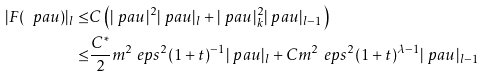<formula> <loc_0><loc_0><loc_500><loc_500>| F ( \ p a u ) | _ { l } \leq & C \left ( | \ p a u | ^ { 2 } | \ p a u | _ { l } + | \ p a u | _ { k } ^ { 2 } | \ p a u | _ { l - 1 } \right ) \\ \leq & \frac { C ^ { * } } { 2 } m ^ { 2 } \ e p s ^ { 2 } ( 1 + t ) ^ { - 1 } | \ p a u | _ { l } + C m ^ { 2 } \ e p s ^ { 2 } ( 1 + t ) ^ { \lambda - 1 } | \ p a u | _ { l - 1 }</formula> 